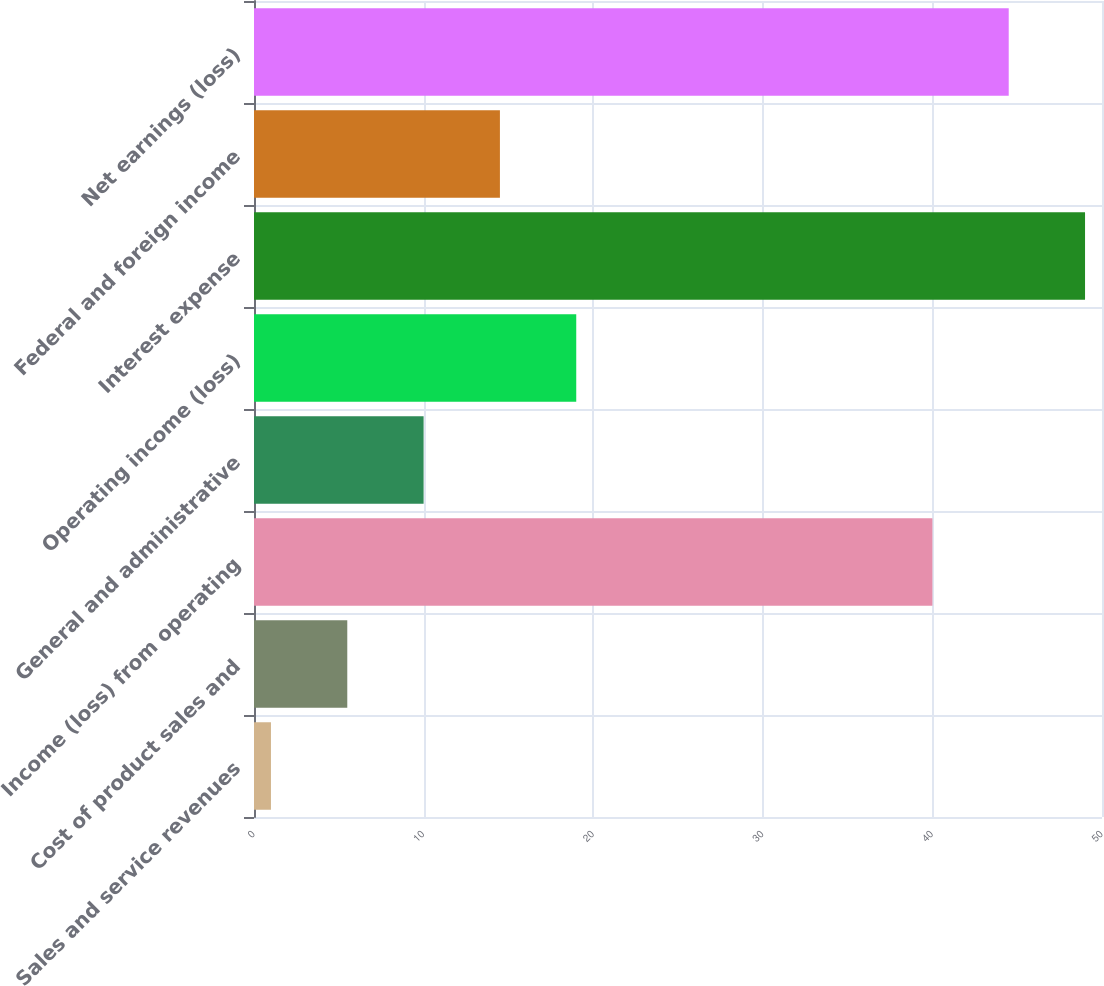Convert chart. <chart><loc_0><loc_0><loc_500><loc_500><bar_chart><fcel>Sales and service revenues<fcel>Cost of product sales and<fcel>Income (loss) from operating<fcel>General and administrative<fcel>Operating income (loss)<fcel>Interest expense<fcel>Federal and foreign income<fcel>Net earnings (loss)<nl><fcel>1<fcel>5.5<fcel>40<fcel>10<fcel>19<fcel>49<fcel>14.5<fcel>44.5<nl></chart> 